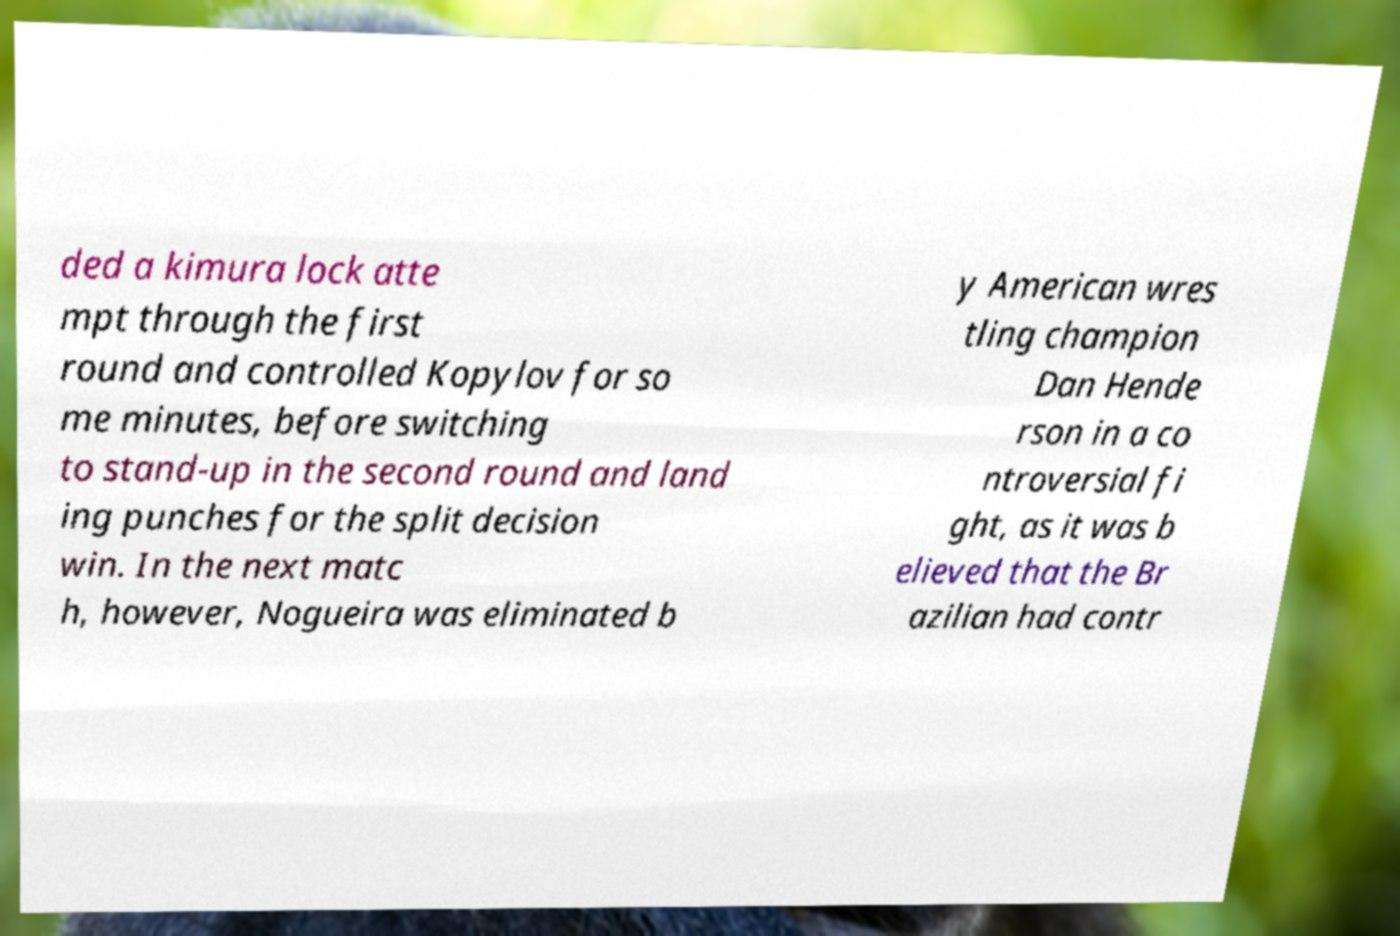For documentation purposes, I need the text within this image transcribed. Could you provide that? ded a kimura lock atte mpt through the first round and controlled Kopylov for so me minutes, before switching to stand-up in the second round and land ing punches for the split decision win. In the next matc h, however, Nogueira was eliminated b y American wres tling champion Dan Hende rson in a co ntroversial fi ght, as it was b elieved that the Br azilian had contr 